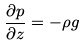Convert formula to latex. <formula><loc_0><loc_0><loc_500><loc_500>\frac { \partial p } { \partial z } = - \rho g</formula> 